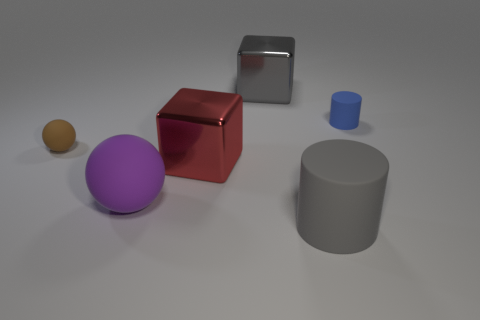How many metallic cubes are the same color as the small cylinder? There are no metallic cubes that are the same color as the small cylinder. The small cylinder is blue, and the only metallic cube present is red. 